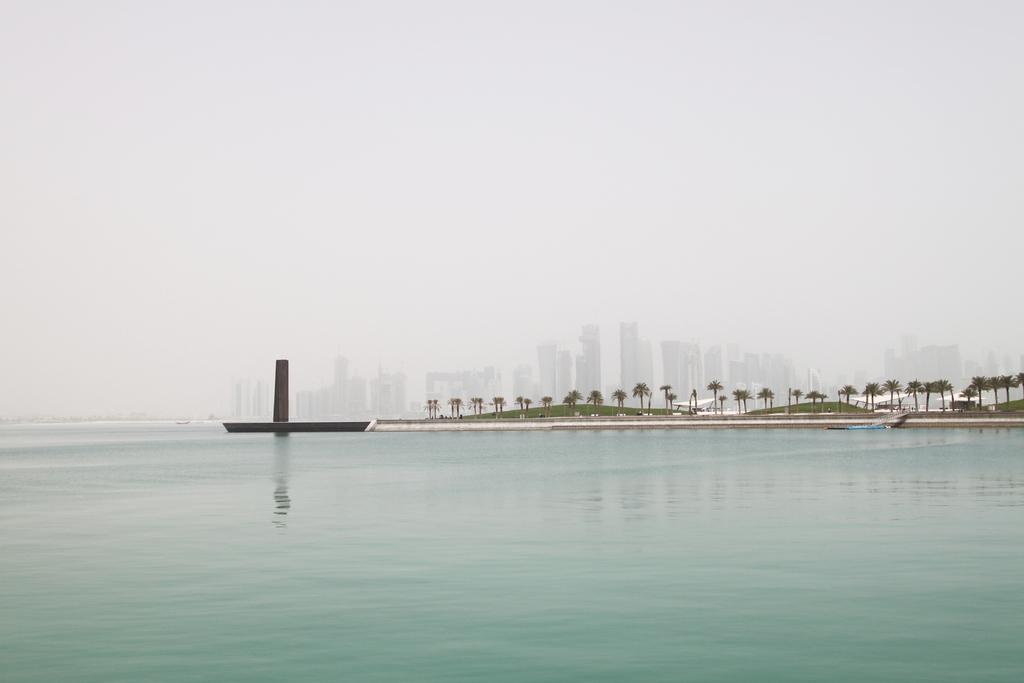What is the primary element visible in the image? There is water in the image. What can be seen in the distance behind the water? There are trees and buildings visible in the background. What architectural feature is present in the image? There is a pillar in the image. What part of the natural environment is visible in the image? The sky is visible in the image. What type of peace is being negotiated in the image? There is no indication of any peace negotiations or discussions in the image; it primarily features water, trees, buildings, a pillar, and the sky. 